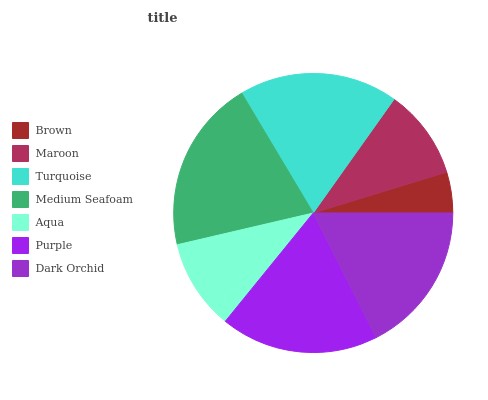Is Brown the minimum?
Answer yes or no. Yes. Is Medium Seafoam the maximum?
Answer yes or no. Yes. Is Maroon the minimum?
Answer yes or no. No. Is Maroon the maximum?
Answer yes or no. No. Is Maroon greater than Brown?
Answer yes or no. Yes. Is Brown less than Maroon?
Answer yes or no. Yes. Is Brown greater than Maroon?
Answer yes or no. No. Is Maroon less than Brown?
Answer yes or no. No. Is Dark Orchid the high median?
Answer yes or no. Yes. Is Dark Orchid the low median?
Answer yes or no. Yes. Is Turquoise the high median?
Answer yes or no. No. Is Maroon the low median?
Answer yes or no. No. 